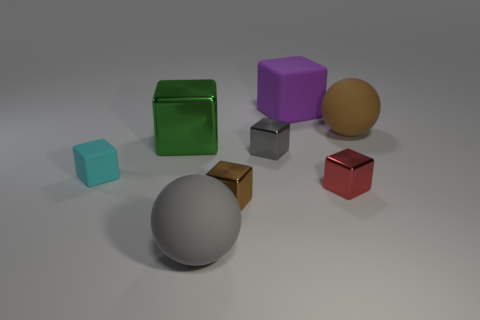Subtract 3 blocks. How many blocks are left? 3 Subtract all cyan blocks. How many blocks are left? 5 Subtract all purple cubes. How many cubes are left? 5 Subtract all blue cubes. Subtract all purple balls. How many cubes are left? 6 Add 1 tiny gray metallic blocks. How many objects exist? 9 Subtract all blocks. How many objects are left? 2 Add 2 cyan rubber objects. How many cyan rubber objects are left? 3 Add 2 green metallic things. How many green metallic things exist? 3 Subtract 1 green blocks. How many objects are left? 7 Subtract all big brown objects. Subtract all tiny gray cubes. How many objects are left? 6 